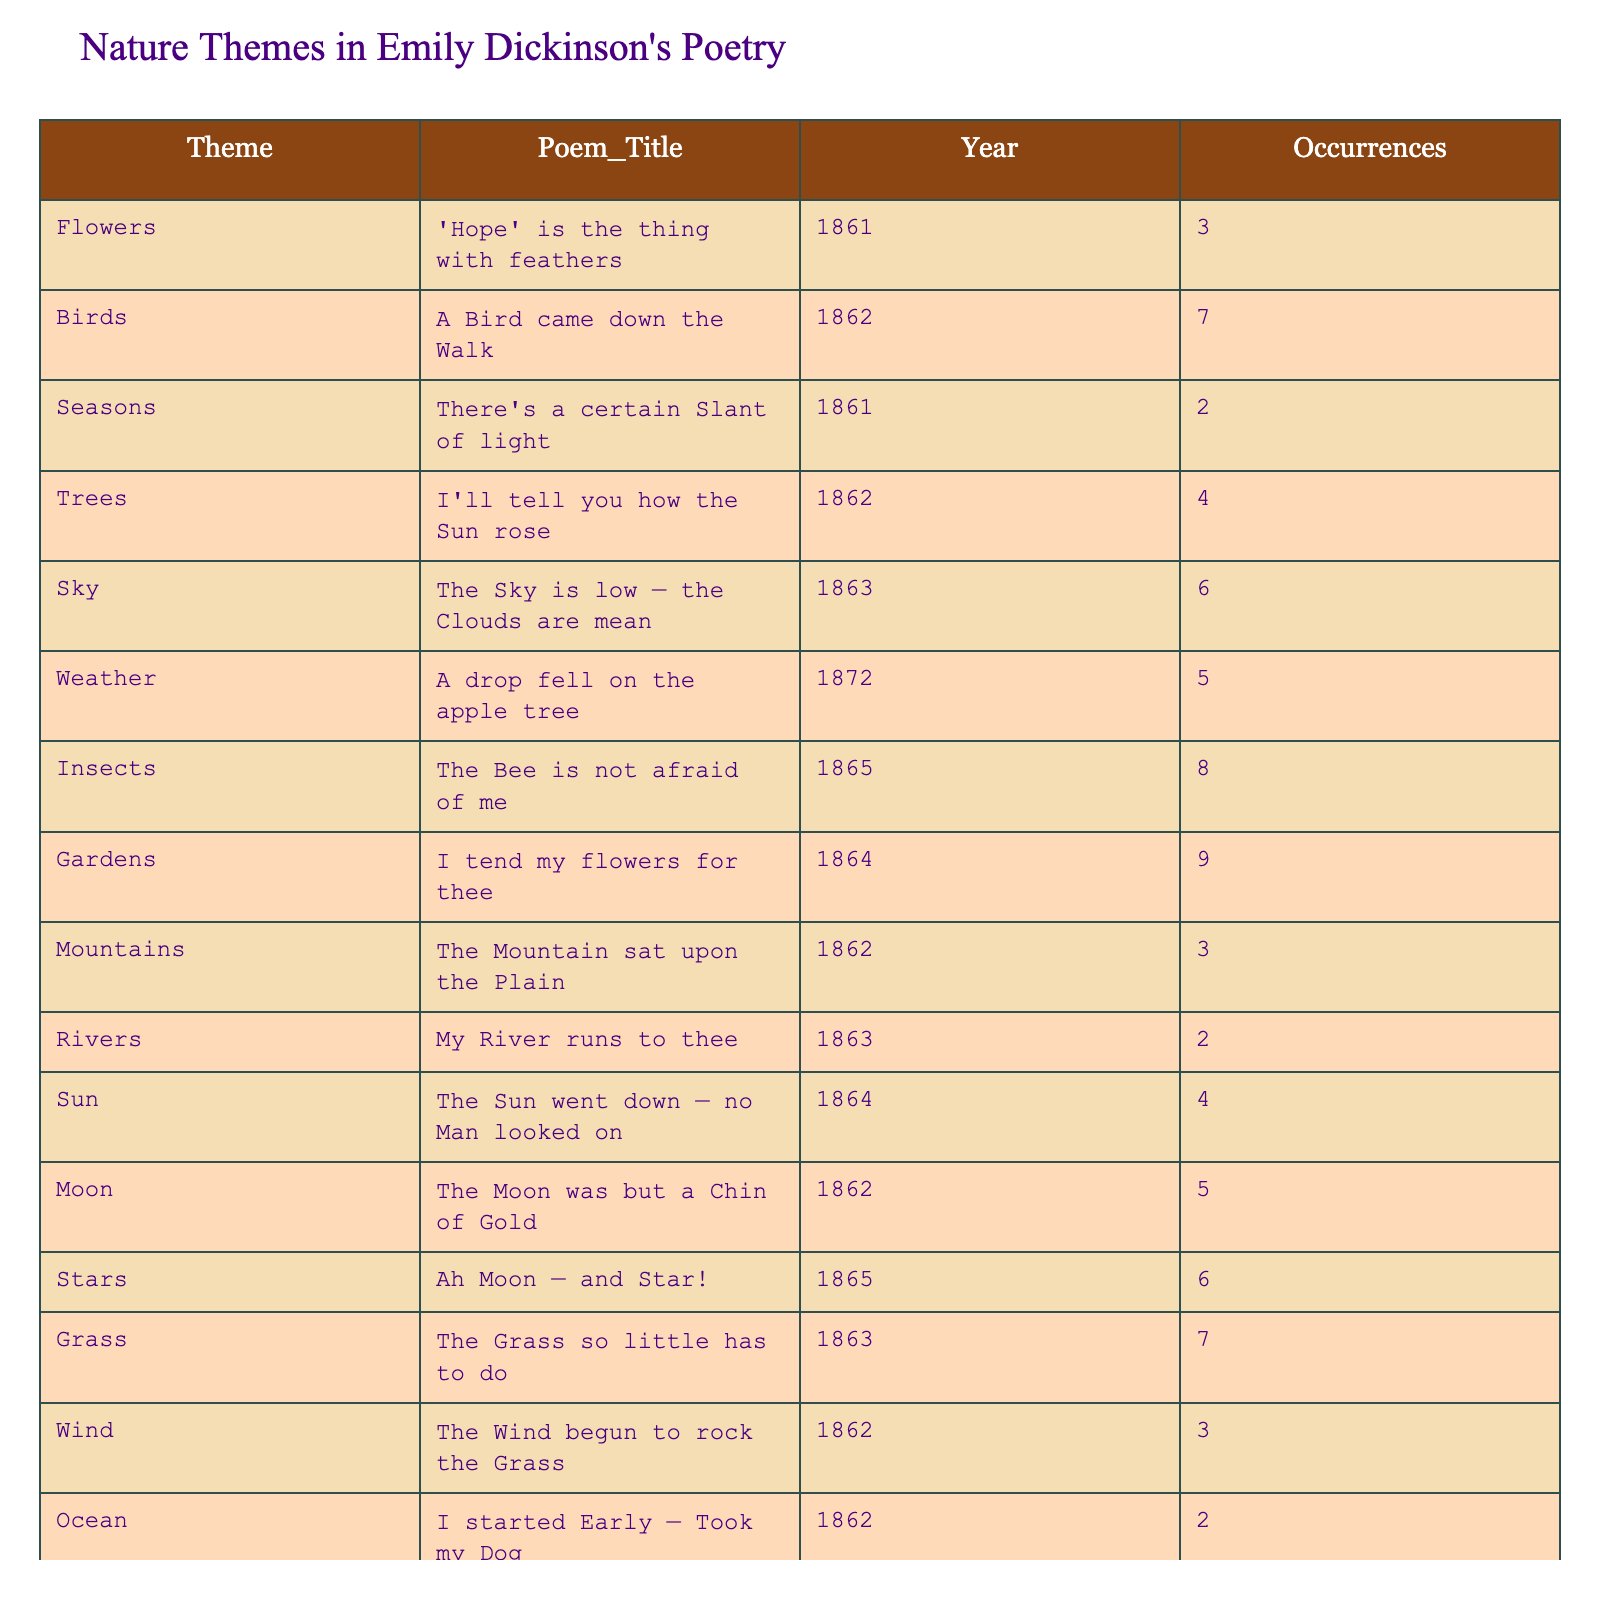What is the total number of occurrences of nature-related themes in Emily Dickinson's poems? To find the total occurrences, I will sum the occurrences for each theme listed in the table. Adding all the occurrences gives: 3 + 7 + 2 + 4 + 6 + 5 + 8 + 9 + 3 + 2 + 4 + 5 + 6 + 7 + 3 + 2 + 5 + 4 + 6 + 3 = 81.
Answer: 81 Which poem has the highest number of occurrences of nature-related themes? By examining the occurrences for each poem, "I tend my flowers for thee" has the highest count of 9 occurrences.
Answer: "I tend my flowers for thee" What is the average number of occurrences for the themes related to flowers, trees, and gardens? To calculate the average for these three themes, I will sum their occurrences: Flowers (3) + Trees (4) + Gardens (9) = 16, then divide by 3 to get the average: 16 / 3 = 5.33.
Answer: 5.33 Is the number of occurrences of the theme "Insects" greater than the occurrences of "Wind"? Comparing the occurrences of "Insects" which is 8 and "Wind" which is 3, 8 is greater than 3, making the statement true.
Answer: True What is the difference in occurrences between the themes "Sun" and "Moon"? The occurrences for the "Sun" is 4 and for the "Moon" is 5. The difference is calculated by subtracting the lesser from the greater: 5 - 4 = 1.
Answer: 1 How many poems from 1862 contain nature-related themes, and what is their total occurrence count? The years indicated in the table with 1862 are: "A Bird came down the Walk," "I'll tell you how the Sun rose," "The Moon was but a Chin of Gold," "From Cocoon forth a Butterfly," and "The Wind begun to rock the Grass," which have 7, 5, 5, 6, and 3 occurrences respectively. Adding these gives 7 + 5 + 5 + 6 + 3 = 26. There are 5 poems.
Answer: 26 occurrences from 5 poems Identify the theme with the least occurrences and its corresponding poem. Looking at all occurrences, "Ocean" has the least occurrences with a count of 2 in the poem "I started Early — Took my Dog."
Answer: "Ocean," "I started Early — Took my Dog" What percentage of the total occurrences do the themes related to the sky (Sky and Stars) contribute? The contributions from "Sky" (6 occurrences) and "Stars" (6 occurrences) sum up to 12. The percentage is then calculated as (12 / 81) * 100 which is approximately 14.81%.
Answer: Approximately 14.81% Which themes occurring in 1863 have more than 5 occurrences? The themes in 1863 are "Sky" (6), "Grass" (7), and "Stars" (6). The themes with more than 5 occurrences are "Sky," "Grass," and "Stars."
Answer: Sky, Grass, Stars If we combine the occurrences of "Sunrise" and "Sunset," how do they relate to "Weather"? "Sunrise" has 5 occurrences and "Sunset" has 4; combining them yields 5 + 4 = 9. Comparing this to "Weather," which has 5, 9 is greater, making the conclusion that the sum of "Sunrise" and "Sunset" exceeds "Weather."
Answer: Exceeds 